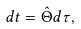<formula> <loc_0><loc_0><loc_500><loc_500>d t = \hat { \Theta } d \tau ,</formula> 